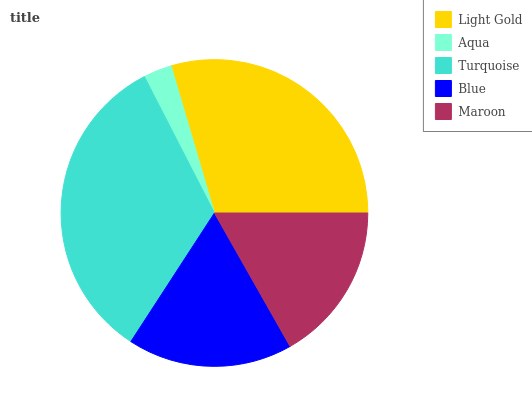Is Aqua the minimum?
Answer yes or no. Yes. Is Turquoise the maximum?
Answer yes or no. Yes. Is Turquoise the minimum?
Answer yes or no. No. Is Aqua the maximum?
Answer yes or no. No. Is Turquoise greater than Aqua?
Answer yes or no. Yes. Is Aqua less than Turquoise?
Answer yes or no. Yes. Is Aqua greater than Turquoise?
Answer yes or no. No. Is Turquoise less than Aqua?
Answer yes or no. No. Is Blue the high median?
Answer yes or no. Yes. Is Blue the low median?
Answer yes or no. Yes. Is Turquoise the high median?
Answer yes or no. No. Is Turquoise the low median?
Answer yes or no. No. 